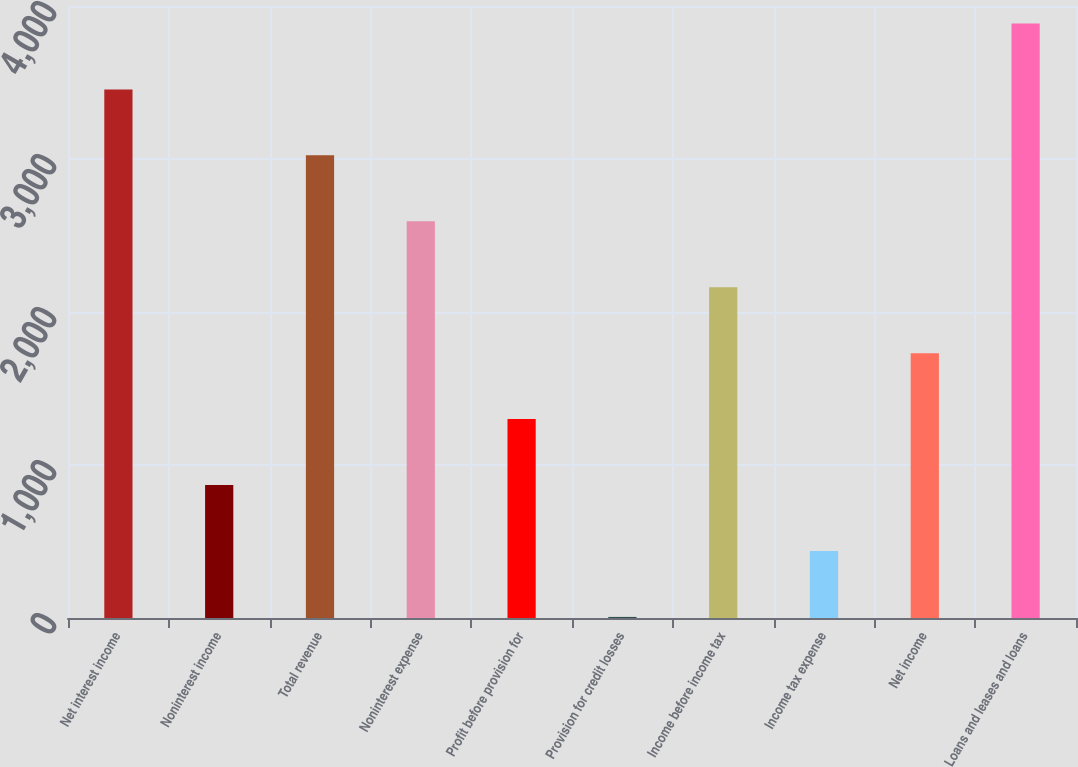Convert chart to OTSL. <chart><loc_0><loc_0><loc_500><loc_500><bar_chart><fcel>Net interest income<fcel>Noninterest income<fcel>Total revenue<fcel>Noninterest expense<fcel>Profit before provision for<fcel>Provision for credit losses<fcel>Income before income tax<fcel>Income tax expense<fcel>Net income<fcel>Loans and leases and loans<nl><fcel>3455<fcel>869<fcel>3024<fcel>2593<fcel>1300<fcel>7<fcel>2162<fcel>438<fcel>1731<fcel>3886<nl></chart> 